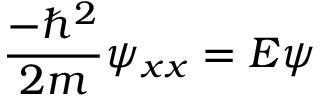<formula> <loc_0><loc_0><loc_500><loc_500>{ \frac { - \hbar { ^ } { 2 } } { 2 m } } \psi _ { x x } = E \psi</formula> 